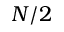<formula> <loc_0><loc_0><loc_500><loc_500>N / 2</formula> 